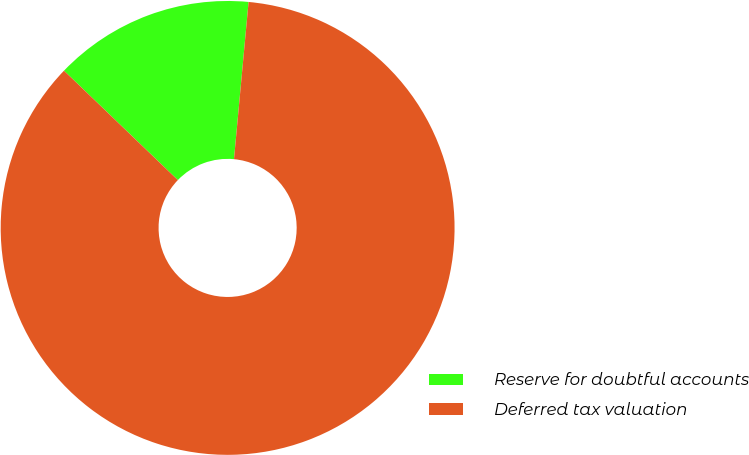Convert chart to OTSL. <chart><loc_0><loc_0><loc_500><loc_500><pie_chart><fcel>Reserve for doubtful accounts<fcel>Deferred tax valuation<nl><fcel>14.29%<fcel>85.71%<nl></chart> 